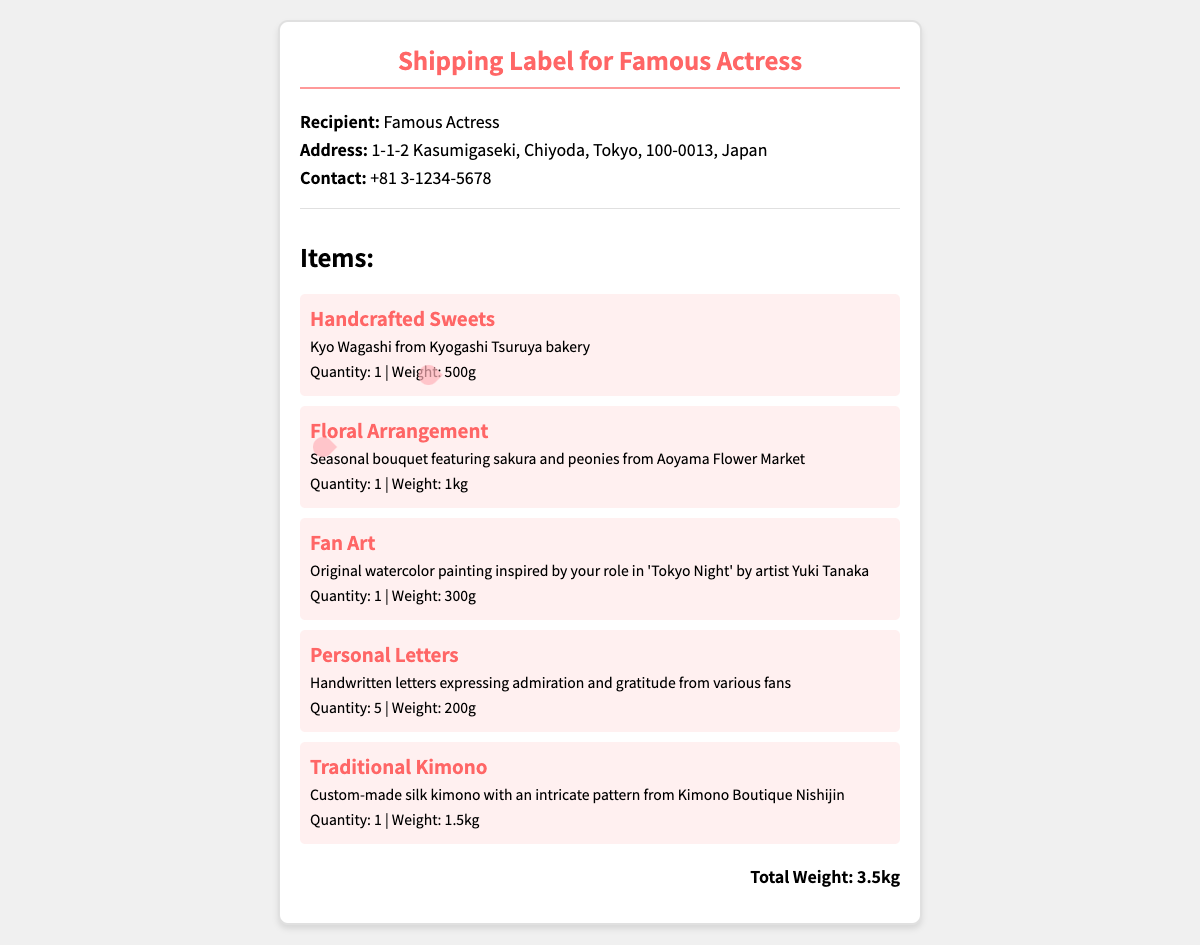what is the recipient's address? The address of the recipient is clearly stated in the document.
Answer: 1-1-2 Kasumigaseki, Chiyoda, Tokyo, 100-0013, Japan what is the total weight of the package? The total weight is mentioned in the document, summarizing the weights of all items included.
Answer: 3.5kg who is the artist of the fan art? The artist's name is provided for the fan art item listed in the document.
Answer: Yuki Tanaka how many handwritten letters are included? The document specifies the quantity of personal letters sent in the package.
Answer: 5 what type of sweets are included? The item name and description for sweets provide specific information about what kind they are.
Answer: Handcrafted Sweets which flower types are featured in the bouquet? The description of the floral arrangement mentions specific flower types included in the item.
Answer: Sakura and peonies what is the weight of the traditional kimono? The document provides the weight of the traditional kimono listed among the items.
Answer: 1.5kg what is the quantity of floral arrangements? The quantity for the floral arrangement is specified in the item details section of the document.
Answer: 1 what is the background color of the shipping label? The background color for the shipping label is mentioned in the styling section of the document.
Answer: White 